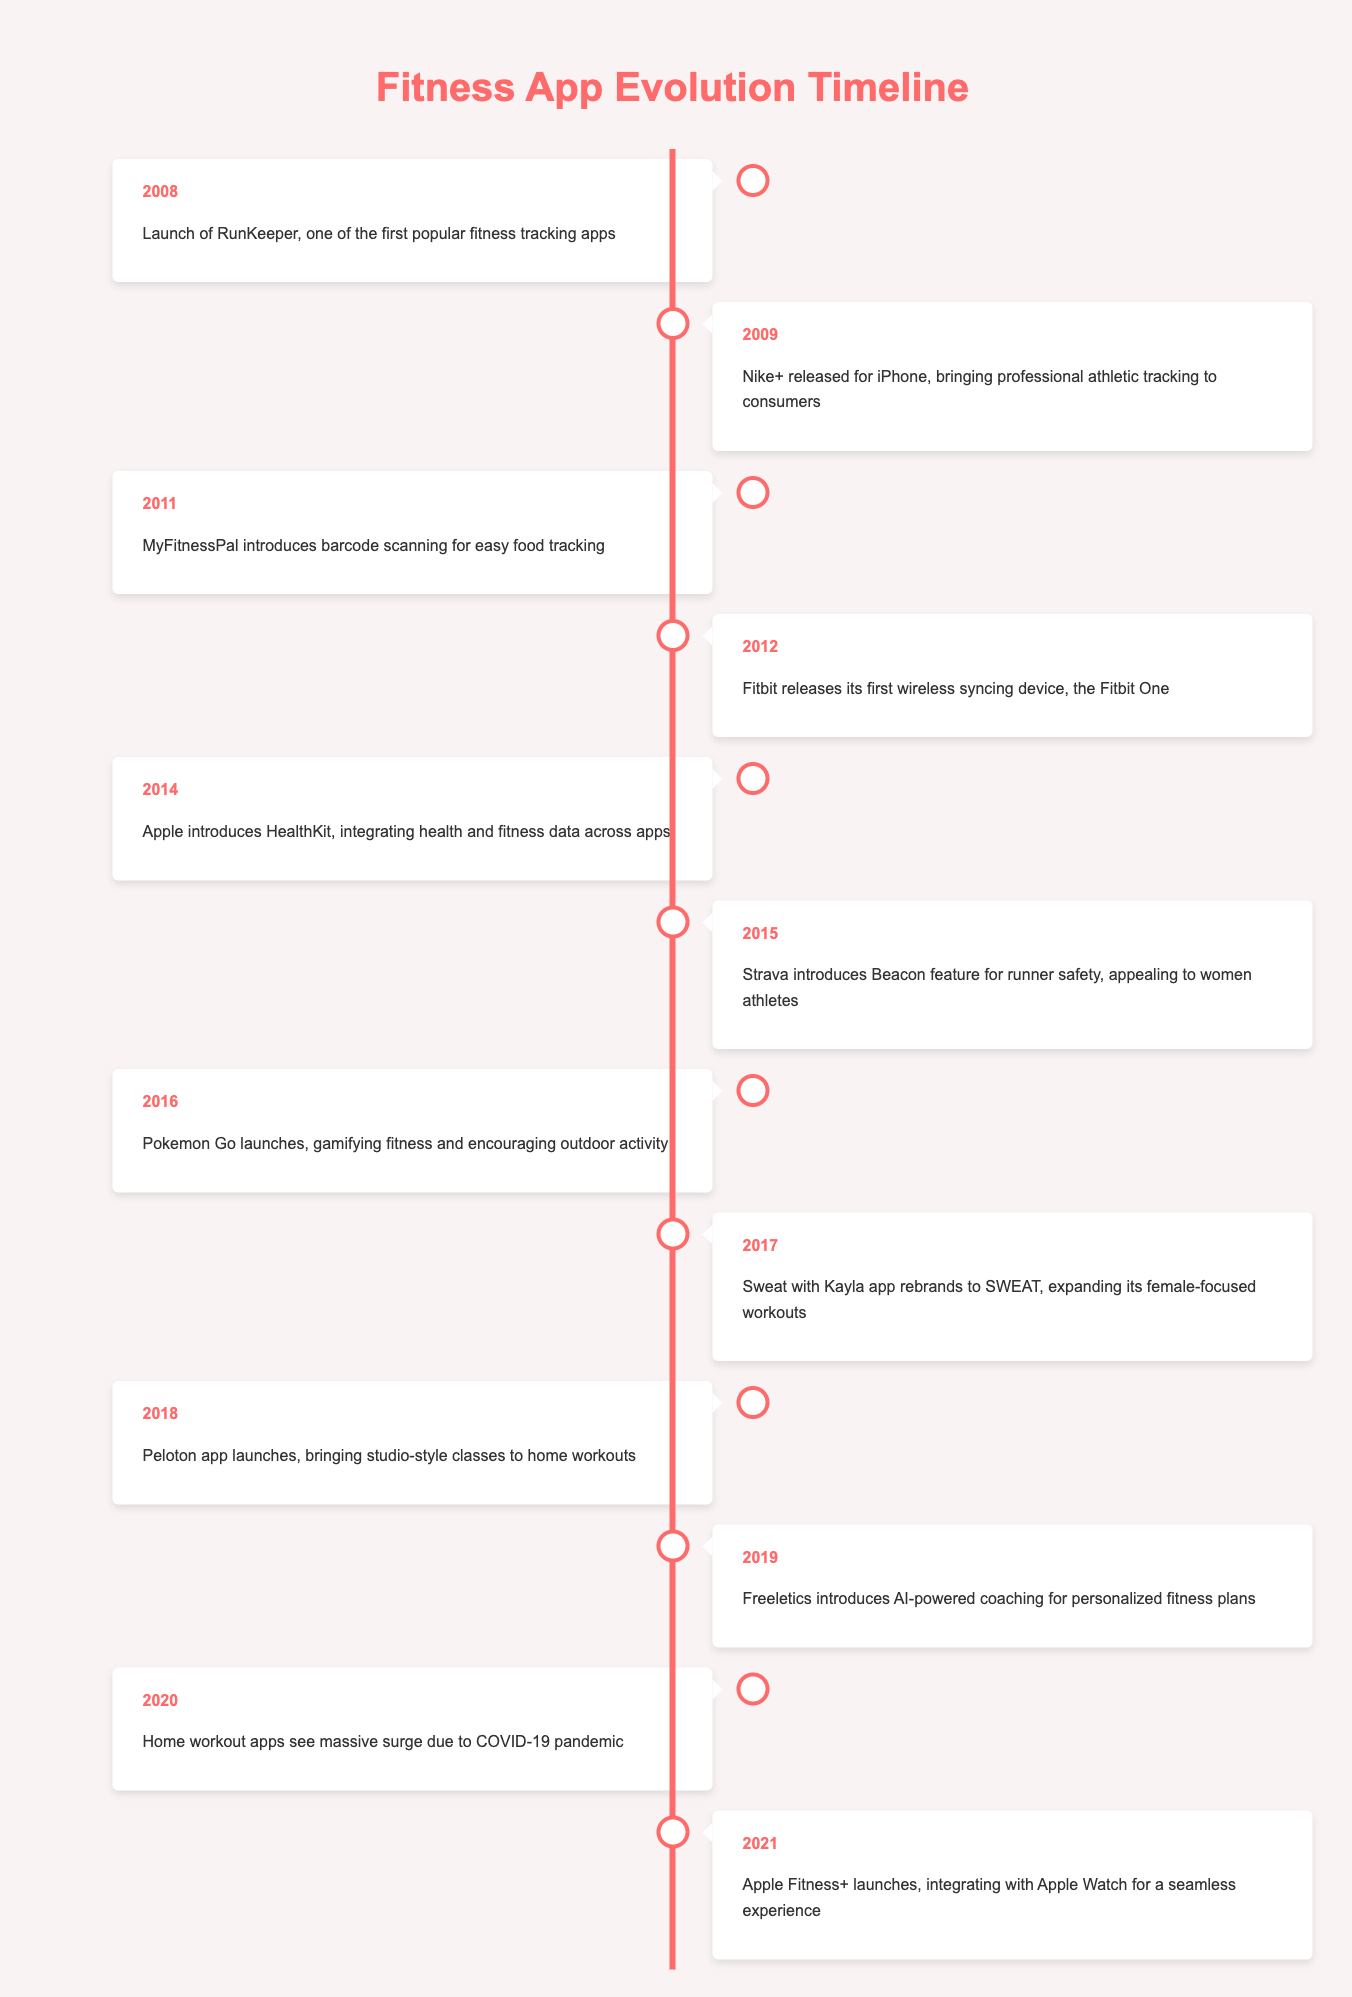What was the first fitness app launched according to the timeline? The timeline indicates that RunKeeper was launched in 2008, making it the first fitness tracking app listed.
Answer: RunKeeper Which app introduced barcode scanning for food tracking, and in what year? The timeline shows that MyFitnessPal introduced barcode scanning for easy food tracking in 2011.
Answer: MyFitnessPal, 2011 How many years passed between the launch of Nike+ and Apple Fitness+? Nike+ was launched in 2009, and Apple Fitness+ was launched in 2021. The years between are calculated as 2021 - 2009 = 12 years.
Answer: 12 years Did Strava's Beacon feature focus solely on male athletes? The timeline states that Strava's Beacon feature appealed to women athletes, indicating that it was not focused solely on male athletes.
Answer: No What major event occurred in the fitness app market in 2020, and what was its cause? In 2020, the timeline notes that home workout apps saw a massive surge due to the COVID-19 pandemic, showcasing a significant event triggered by a global circumstance.
Answer: Surge in home workout apps due to COVID-19 How many fitness apps were launched between 2008 and 2016, inclusive? The timeline lists apps launched every year from 2008 to 2016: RunKeeper (2008), Nike+ (2009), MyFitnessPal (2011), Fitbit (2012), HealthKit (2014), Strava (2015), and Pokemon Go (2016), creating a total count of 7 apps.
Answer: 7 apps What was the focus of the Sweat with Kayla app after rebranding in 2017? The timeline indicates that after rebranding in 2017, the Sweat with Kayla app expanded its female-focused workouts, showing a commitment to targeting women in fitness.
Answer: Female-focused workouts Which fitness app was launched first, Peloton or Freeletics? The timeline shows Peloton launched in 2018 and Freeletics launched in 2019. Therefore, Peloton was released first.
Answer: Peloton How did the launch of HealthKit in 2014 impact data integration in fitness apps? The timeline notes that HealthKit integrated health and fitness data across apps, which implies a significant improvement in how data was shared and utilized among different fitness applications in 2014.
Answer: Integrated health and fitness data across apps What feature was unique to the Beacon introduced by Strava in 2015? The timeline specifies that Beacon was a feature focused on runner safety and particularly held an appeal to women athletes, setting it apart from other features available at the time.
Answer: Runner safety, appealing to women athletes 